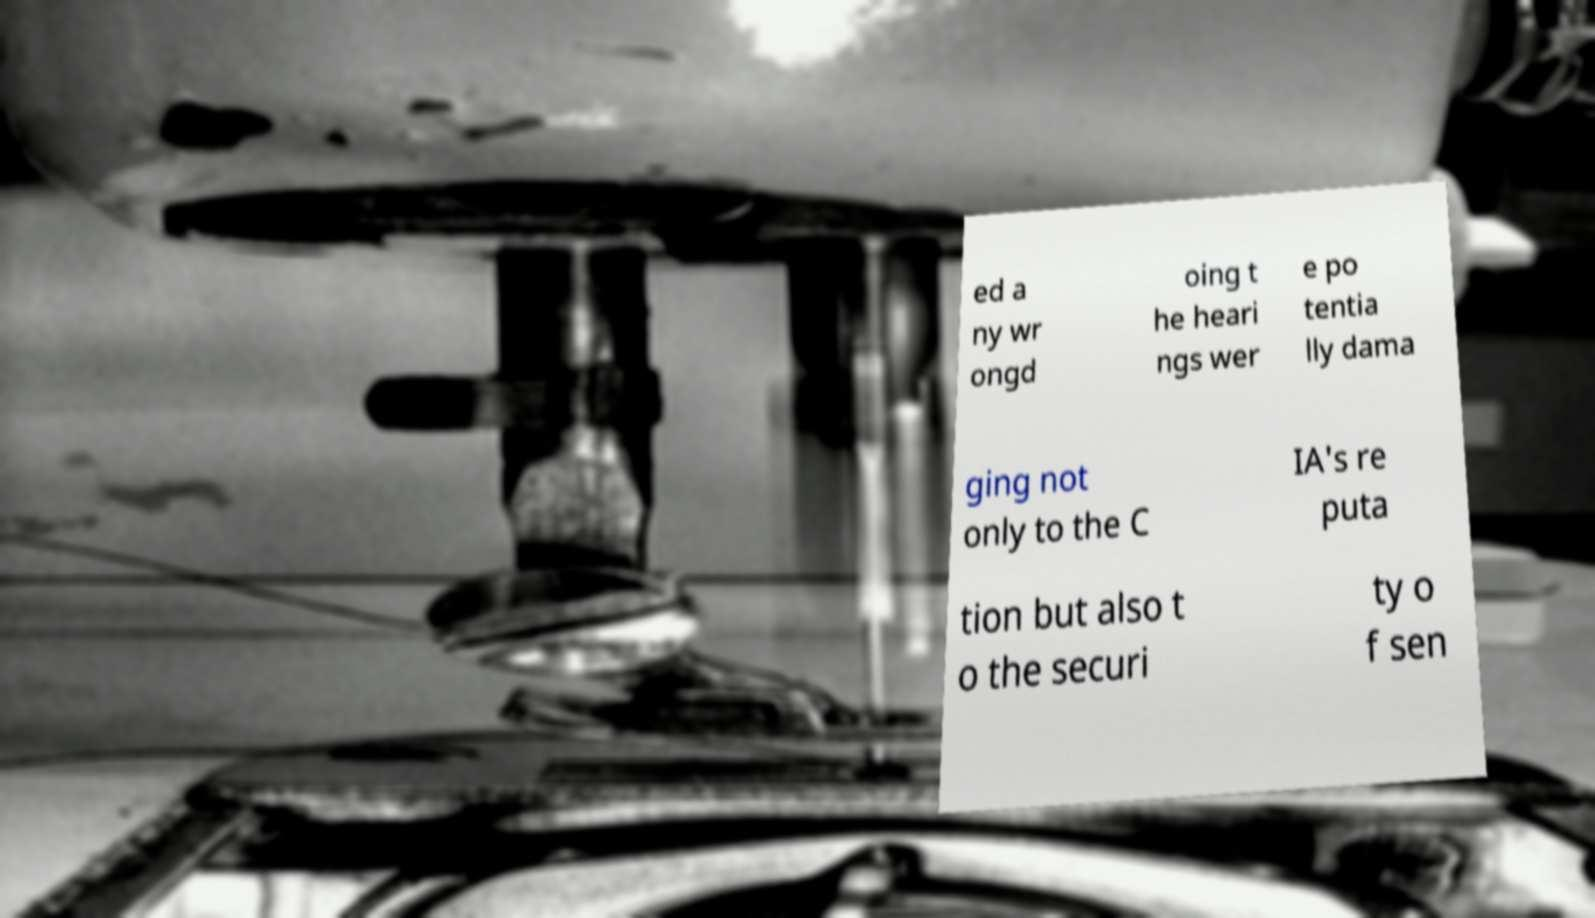Please read and relay the text visible in this image. What does it say? ed a ny wr ongd oing t he heari ngs wer e po tentia lly dama ging not only to the C IA's re puta tion but also t o the securi ty o f sen 